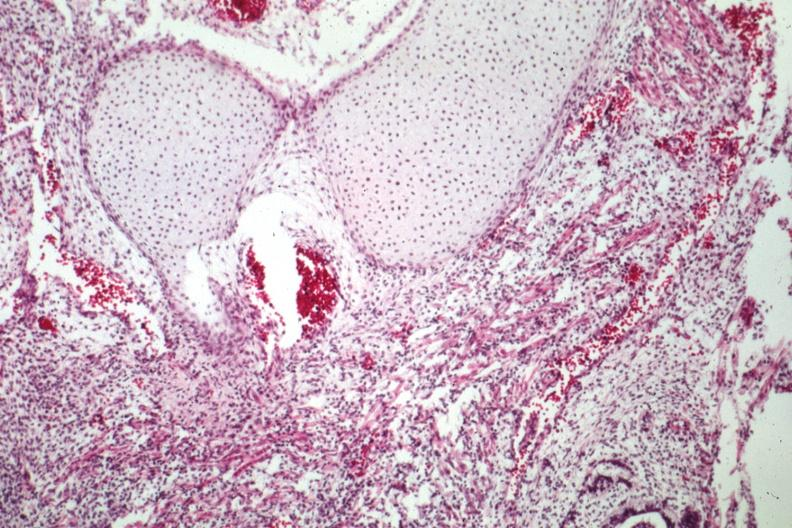does this image show lung tissue and cartilage?
Answer the question using a single word or phrase. Yes 